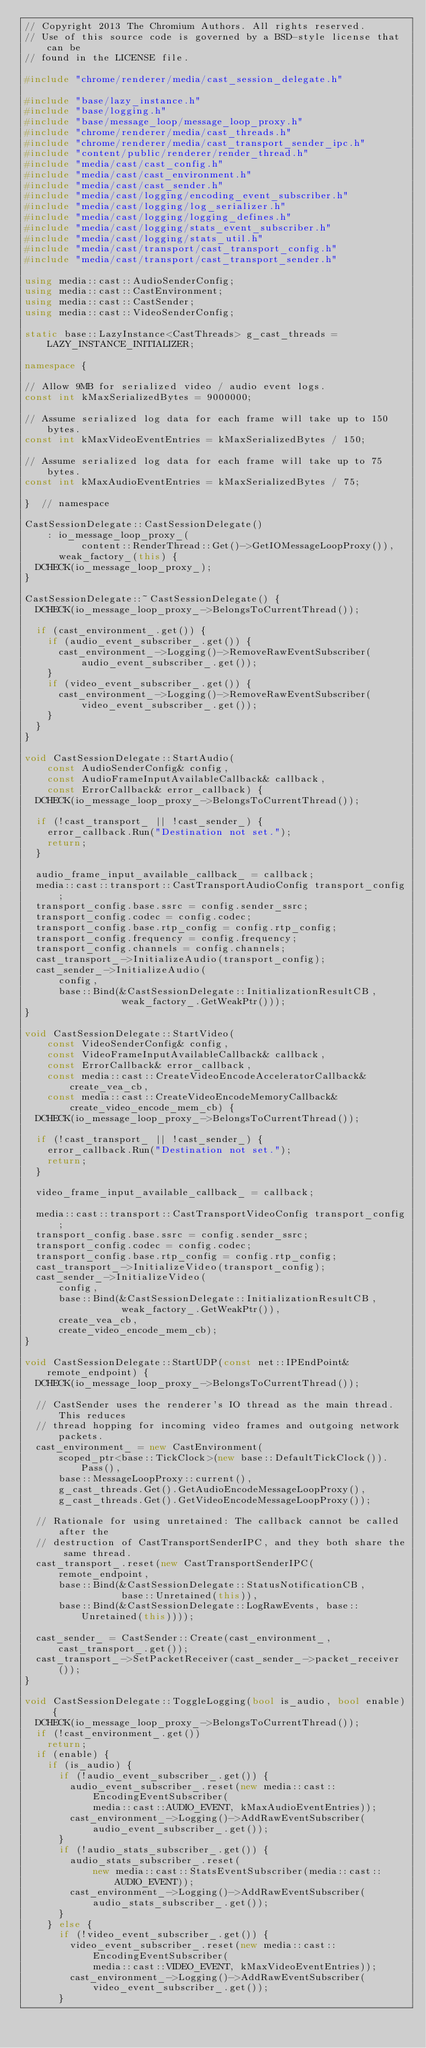Convert code to text. <code><loc_0><loc_0><loc_500><loc_500><_C++_>// Copyright 2013 The Chromium Authors. All rights reserved.
// Use of this source code is governed by a BSD-style license that can be
// found in the LICENSE file.

#include "chrome/renderer/media/cast_session_delegate.h"

#include "base/lazy_instance.h"
#include "base/logging.h"
#include "base/message_loop/message_loop_proxy.h"
#include "chrome/renderer/media/cast_threads.h"
#include "chrome/renderer/media/cast_transport_sender_ipc.h"
#include "content/public/renderer/render_thread.h"
#include "media/cast/cast_config.h"
#include "media/cast/cast_environment.h"
#include "media/cast/cast_sender.h"
#include "media/cast/logging/encoding_event_subscriber.h"
#include "media/cast/logging/log_serializer.h"
#include "media/cast/logging/logging_defines.h"
#include "media/cast/logging/stats_event_subscriber.h"
#include "media/cast/logging/stats_util.h"
#include "media/cast/transport/cast_transport_config.h"
#include "media/cast/transport/cast_transport_sender.h"

using media::cast::AudioSenderConfig;
using media::cast::CastEnvironment;
using media::cast::CastSender;
using media::cast::VideoSenderConfig;

static base::LazyInstance<CastThreads> g_cast_threads =
    LAZY_INSTANCE_INITIALIZER;

namespace {

// Allow 9MB for serialized video / audio event logs.
const int kMaxSerializedBytes = 9000000;

// Assume serialized log data for each frame will take up to 150 bytes.
const int kMaxVideoEventEntries = kMaxSerializedBytes / 150;

// Assume serialized log data for each frame will take up to 75 bytes.
const int kMaxAudioEventEntries = kMaxSerializedBytes / 75;

}  // namespace

CastSessionDelegate::CastSessionDelegate()
    : io_message_loop_proxy_(
          content::RenderThread::Get()->GetIOMessageLoopProxy()),
      weak_factory_(this) {
  DCHECK(io_message_loop_proxy_);
}

CastSessionDelegate::~CastSessionDelegate() {
  DCHECK(io_message_loop_proxy_->BelongsToCurrentThread());

  if (cast_environment_.get()) {
    if (audio_event_subscriber_.get()) {
      cast_environment_->Logging()->RemoveRawEventSubscriber(
          audio_event_subscriber_.get());
    }
    if (video_event_subscriber_.get()) {
      cast_environment_->Logging()->RemoveRawEventSubscriber(
          video_event_subscriber_.get());
    }
  }
}

void CastSessionDelegate::StartAudio(
    const AudioSenderConfig& config,
    const AudioFrameInputAvailableCallback& callback,
    const ErrorCallback& error_callback) {
  DCHECK(io_message_loop_proxy_->BelongsToCurrentThread());

  if (!cast_transport_ || !cast_sender_) {
    error_callback.Run("Destination not set.");
    return;
  }

  audio_frame_input_available_callback_ = callback;
  media::cast::transport::CastTransportAudioConfig transport_config;
  transport_config.base.ssrc = config.sender_ssrc;
  transport_config.codec = config.codec;
  transport_config.base.rtp_config = config.rtp_config;
  transport_config.frequency = config.frequency;
  transport_config.channels = config.channels;
  cast_transport_->InitializeAudio(transport_config);
  cast_sender_->InitializeAudio(
      config,
      base::Bind(&CastSessionDelegate::InitializationResultCB,
                 weak_factory_.GetWeakPtr()));
}

void CastSessionDelegate::StartVideo(
    const VideoSenderConfig& config,
    const VideoFrameInputAvailableCallback& callback,
    const ErrorCallback& error_callback,
    const media::cast::CreateVideoEncodeAcceleratorCallback& create_vea_cb,
    const media::cast::CreateVideoEncodeMemoryCallback&
        create_video_encode_mem_cb) {
  DCHECK(io_message_loop_proxy_->BelongsToCurrentThread());

  if (!cast_transport_ || !cast_sender_) {
    error_callback.Run("Destination not set.");
    return;
  }

  video_frame_input_available_callback_ = callback;

  media::cast::transport::CastTransportVideoConfig transport_config;
  transport_config.base.ssrc = config.sender_ssrc;
  transport_config.codec = config.codec;
  transport_config.base.rtp_config = config.rtp_config;
  cast_transport_->InitializeVideo(transport_config);
  cast_sender_->InitializeVideo(
      config,
      base::Bind(&CastSessionDelegate::InitializationResultCB,
                 weak_factory_.GetWeakPtr()),
      create_vea_cb,
      create_video_encode_mem_cb);
}

void CastSessionDelegate::StartUDP(const net::IPEndPoint& remote_endpoint) {
  DCHECK(io_message_loop_proxy_->BelongsToCurrentThread());

  // CastSender uses the renderer's IO thread as the main thread. This reduces
  // thread hopping for incoming video frames and outgoing network packets.
  cast_environment_ = new CastEnvironment(
      scoped_ptr<base::TickClock>(new base::DefaultTickClock()).Pass(),
      base::MessageLoopProxy::current(),
      g_cast_threads.Get().GetAudioEncodeMessageLoopProxy(),
      g_cast_threads.Get().GetVideoEncodeMessageLoopProxy());

  // Rationale for using unretained: The callback cannot be called after the
  // destruction of CastTransportSenderIPC, and they both share the same thread.
  cast_transport_.reset(new CastTransportSenderIPC(
      remote_endpoint,
      base::Bind(&CastSessionDelegate::StatusNotificationCB,
                 base::Unretained(this)),
      base::Bind(&CastSessionDelegate::LogRawEvents, base::Unretained(this))));

  cast_sender_ = CastSender::Create(cast_environment_, cast_transport_.get());
  cast_transport_->SetPacketReceiver(cast_sender_->packet_receiver());
}

void CastSessionDelegate::ToggleLogging(bool is_audio, bool enable) {
  DCHECK(io_message_loop_proxy_->BelongsToCurrentThread());
  if (!cast_environment_.get())
    return;
  if (enable) {
    if (is_audio) {
      if (!audio_event_subscriber_.get()) {
        audio_event_subscriber_.reset(new media::cast::EncodingEventSubscriber(
            media::cast::AUDIO_EVENT, kMaxAudioEventEntries));
        cast_environment_->Logging()->AddRawEventSubscriber(
            audio_event_subscriber_.get());
      }
      if (!audio_stats_subscriber_.get()) {
        audio_stats_subscriber_.reset(
            new media::cast::StatsEventSubscriber(media::cast::AUDIO_EVENT));
        cast_environment_->Logging()->AddRawEventSubscriber(
            audio_stats_subscriber_.get());
      }
    } else {
      if (!video_event_subscriber_.get()) {
        video_event_subscriber_.reset(new media::cast::EncodingEventSubscriber(
            media::cast::VIDEO_EVENT, kMaxVideoEventEntries));
        cast_environment_->Logging()->AddRawEventSubscriber(
            video_event_subscriber_.get());
      }</code> 